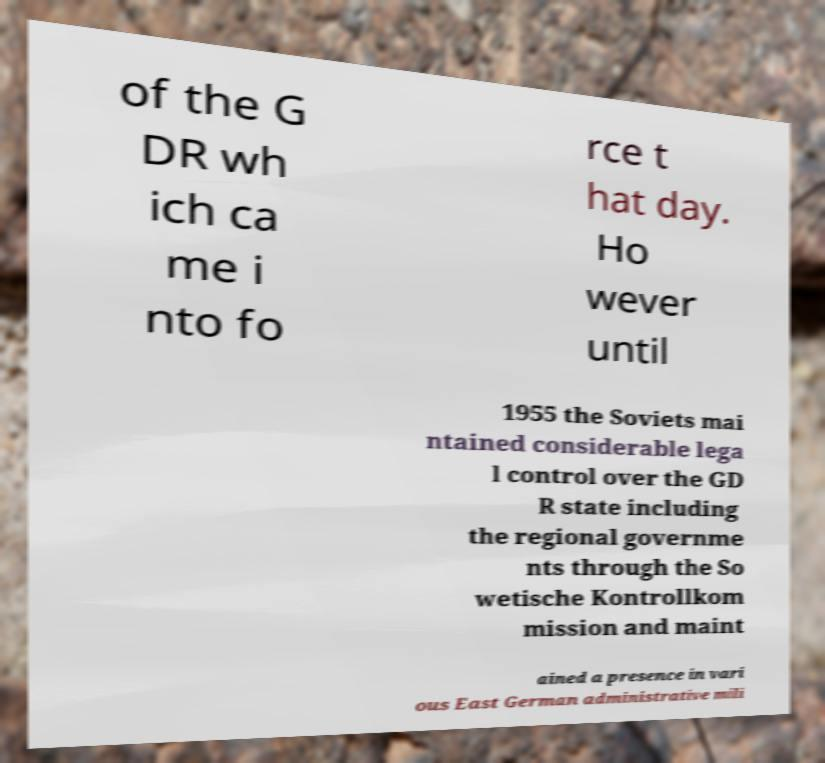Can you accurately transcribe the text from the provided image for me? of the G DR wh ich ca me i nto fo rce t hat day. Ho wever until 1955 the Soviets mai ntained considerable lega l control over the GD R state including the regional governme nts through the So wetische Kontrollkom mission and maint ained a presence in vari ous East German administrative mili 